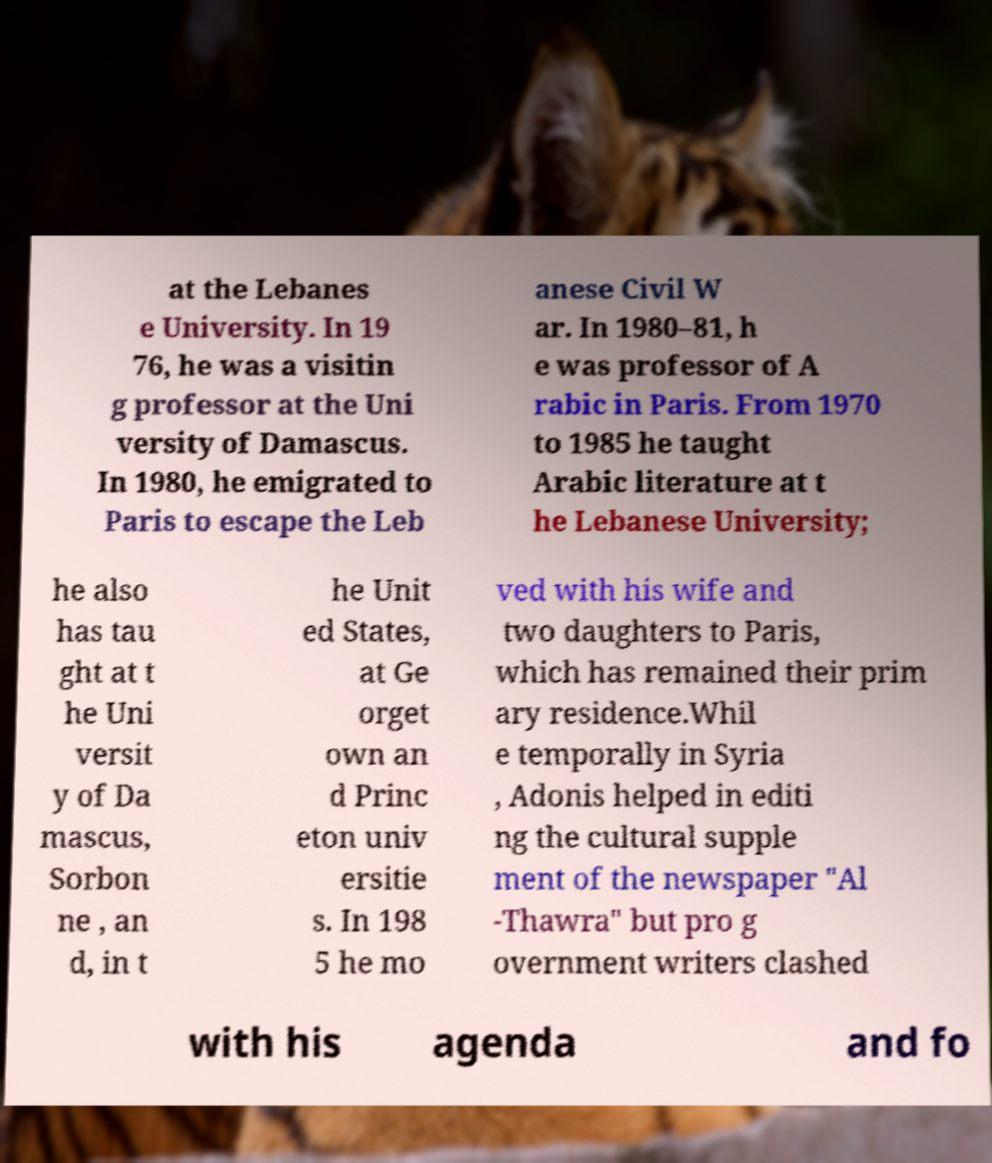Could you extract and type out the text from this image? at the Lebanes e University. In 19 76, he was a visitin g professor at the Uni versity of Damascus. In 1980, he emigrated to Paris to escape the Leb anese Civil W ar. In 1980–81, h e was professor of A rabic in Paris. From 1970 to 1985 he taught Arabic literature at t he Lebanese University; he also has tau ght at t he Uni versit y of Da mascus, Sorbon ne , an d, in t he Unit ed States, at Ge orget own an d Princ eton univ ersitie s. In 198 5 he mo ved with his wife and two daughters to Paris, which has remained their prim ary residence.Whil e temporally in Syria , Adonis helped in editi ng the cultural supple ment of the newspaper "Al -Thawra" but pro g overnment writers clashed with his agenda and fo 